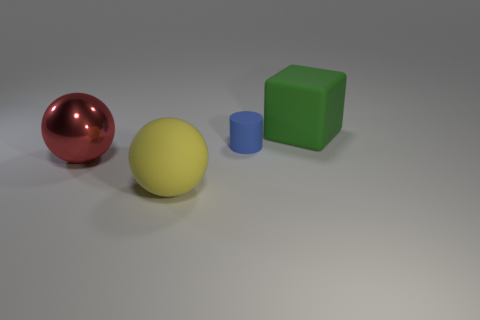Add 3 brown balls. How many objects exist? 7 Subtract all red balls. How many balls are left? 1 Subtract all blocks. How many objects are left? 3 Subtract all gray spheres. Subtract all cyan cylinders. How many spheres are left? 2 Subtract all rubber things. Subtract all blue objects. How many objects are left? 0 Add 1 green objects. How many green objects are left? 2 Add 3 blue cubes. How many blue cubes exist? 3 Subtract 0 brown balls. How many objects are left? 4 